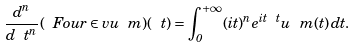<formula> <loc_0><loc_0><loc_500><loc_500>\frac { d ^ { n } } { d \ t ^ { n } } ( \ F o u r \in v u _ { \ } m ) ( \ t ) = \int _ { 0 } ^ { + \infty } ( i t ) ^ { n } e ^ { i t \ t } u _ { \ } m ( t ) \, d t .</formula> 